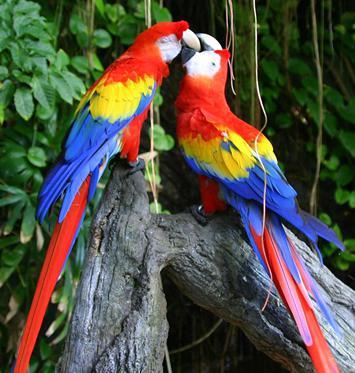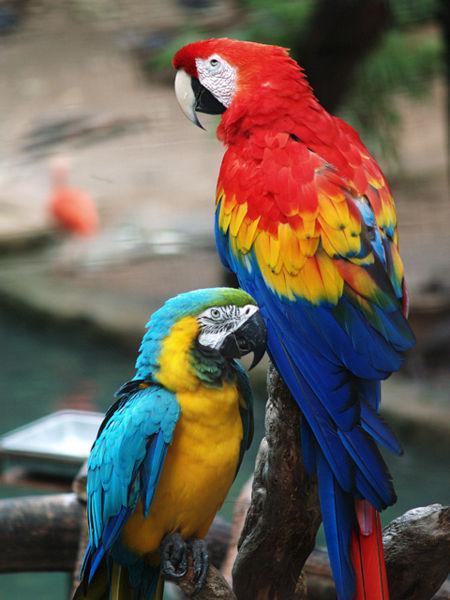The first image is the image on the left, the second image is the image on the right. Considering the images on both sides, is "The image on the right contains one parrot with blue wings closest to the left of the image." valid? Answer yes or no. Yes. 